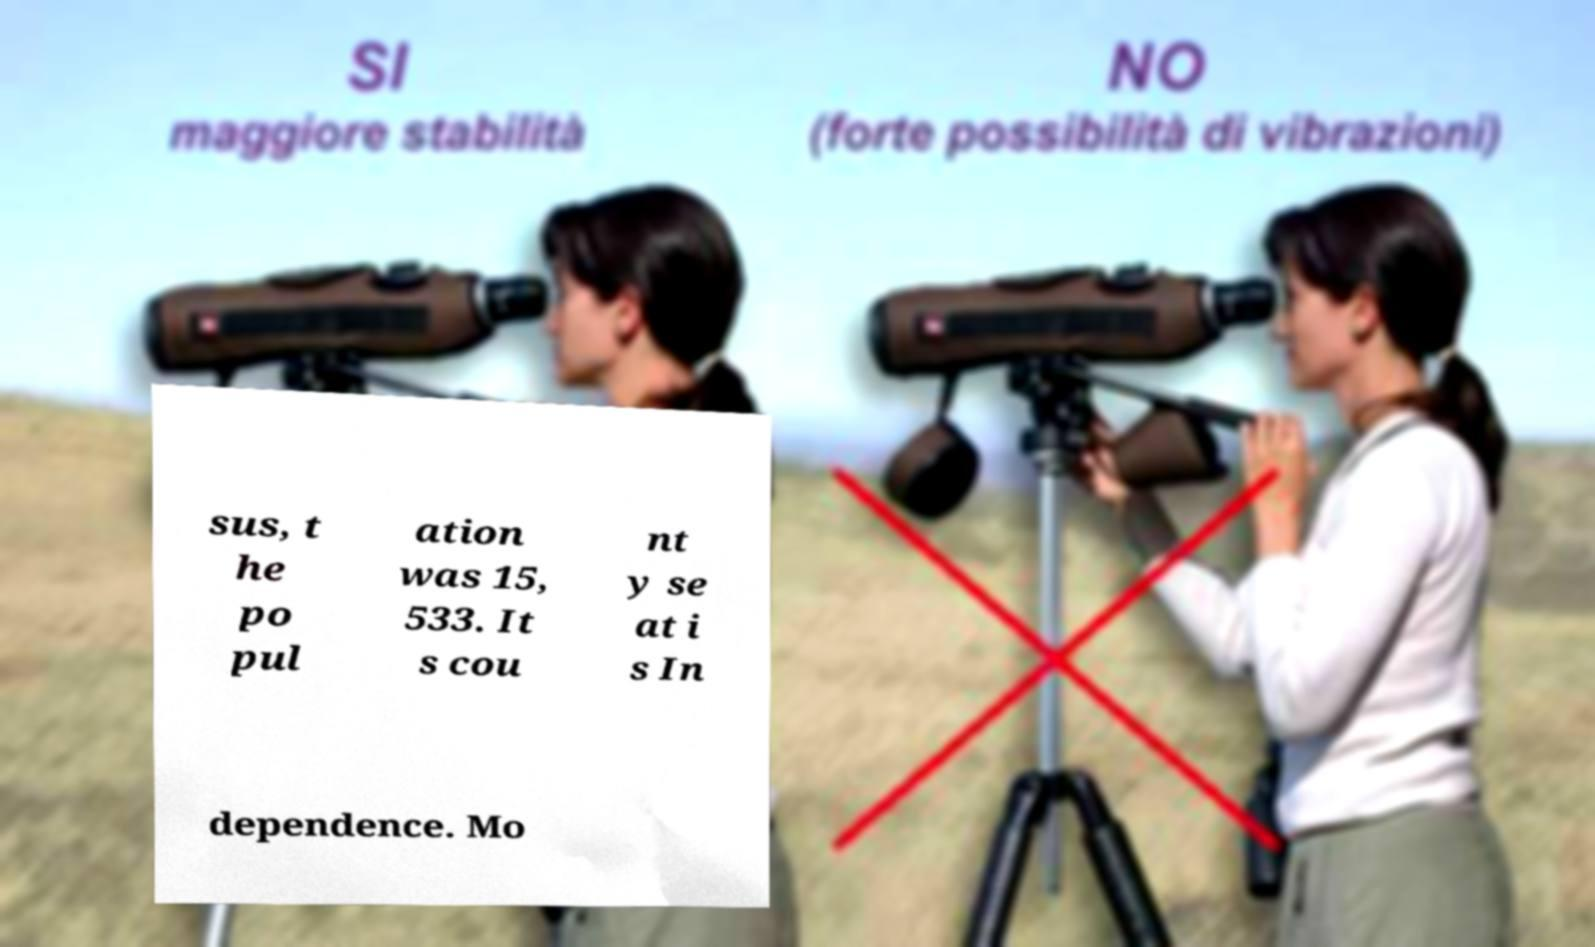Can you read and provide the text displayed in the image?This photo seems to have some interesting text. Can you extract and type it out for me? sus, t he po pul ation was 15, 533. It s cou nt y se at i s In dependence. Mo 